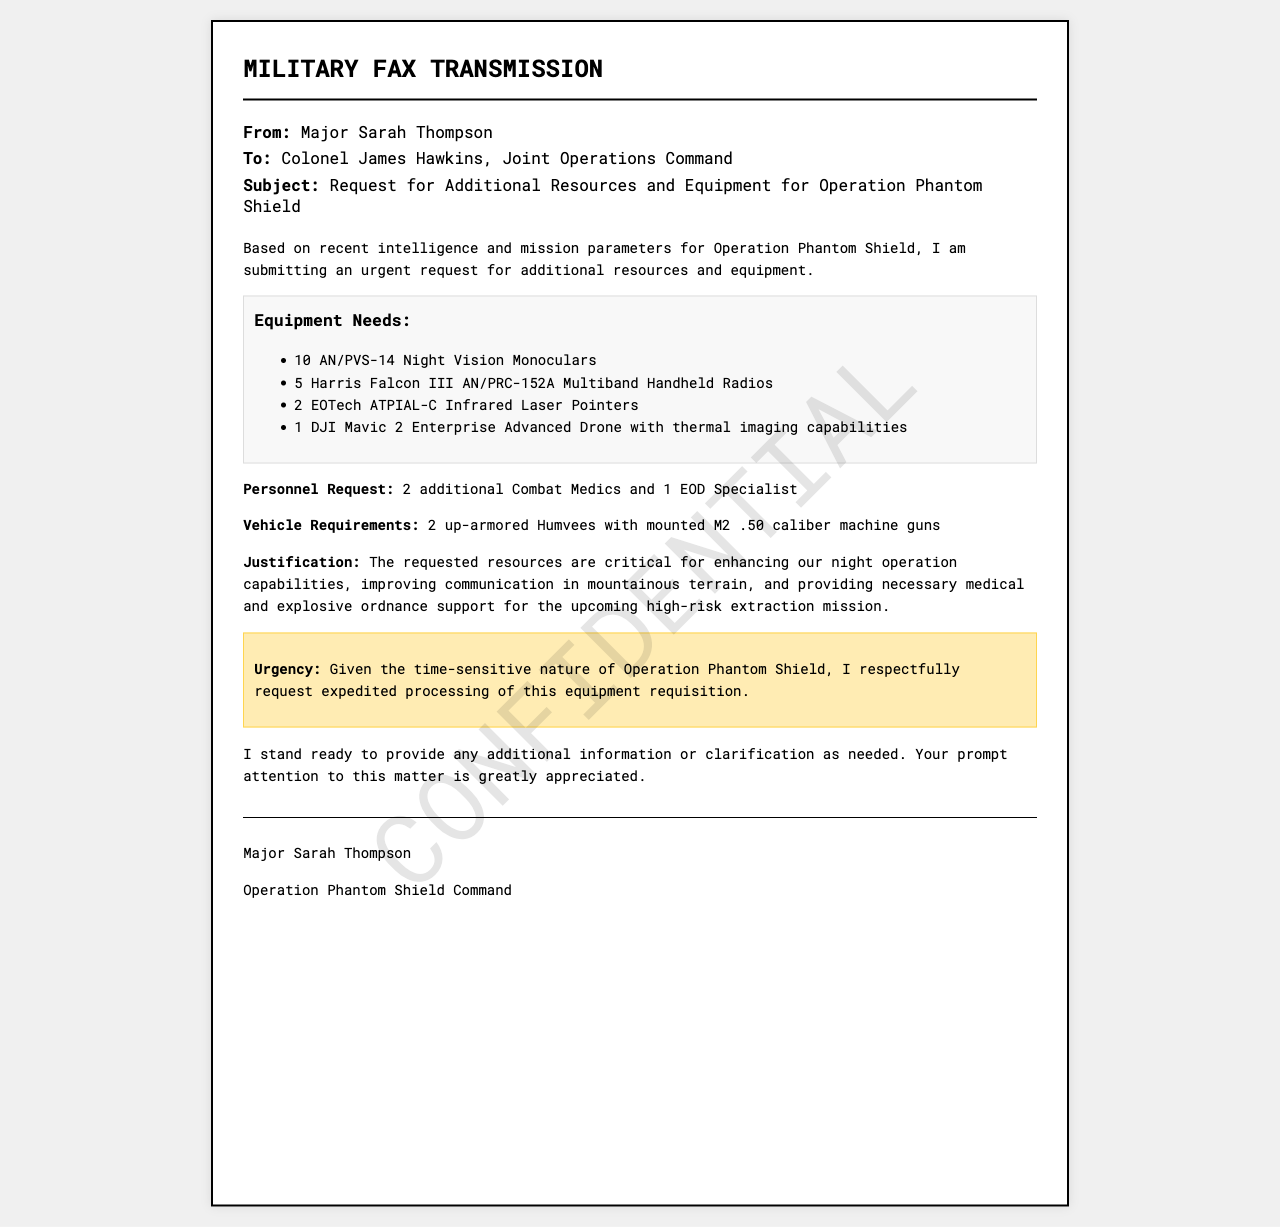what is the name of the sender? The sender is Major Sarah Thompson, as indicated in the "From" section of the fax.
Answer: Major Sarah Thompson who is the recipient of the fax? The recipient is Colonel James Hawkins, mentioned in the "To" section of the document.
Answer: Colonel James Hawkins what is the subject of the fax? The subject of the fax details the request for resources and equipment related to a specific operation.
Answer: Request for Additional Resources and Equipment for Operation Phantom Shield how many Night Vision Monoculars are requested? The request lists the number of Night Vision Monoculars needed clearly stated in the equipment list.
Answer: 10 what type of vehicle is required? The document specifies the type of vehicles needed in the vehicle requirements section.
Answer: up-armored Humvees how many personnel are requested? The document provides a specific number of additional personnel, including descriptions of their roles.
Answer: 3 what is the urgency of this request? The urgency is emphasized in a particular section, reflecting the time-sensitive nature of the request.
Answer: expedited processing what is the purpose of the requested drone? The drone's capabilities are highlighted to clarify its intended use in the operation.
Answer: thermal imaging capabilities how many radios are requested? The number of radios requested is indicated in the equipment list of the document.
Answer: 5 what kind of specialist is needed in addition to the medics? The document specifies a particular type of specialist needed for support in the mission.
Answer: EOD Specialist 